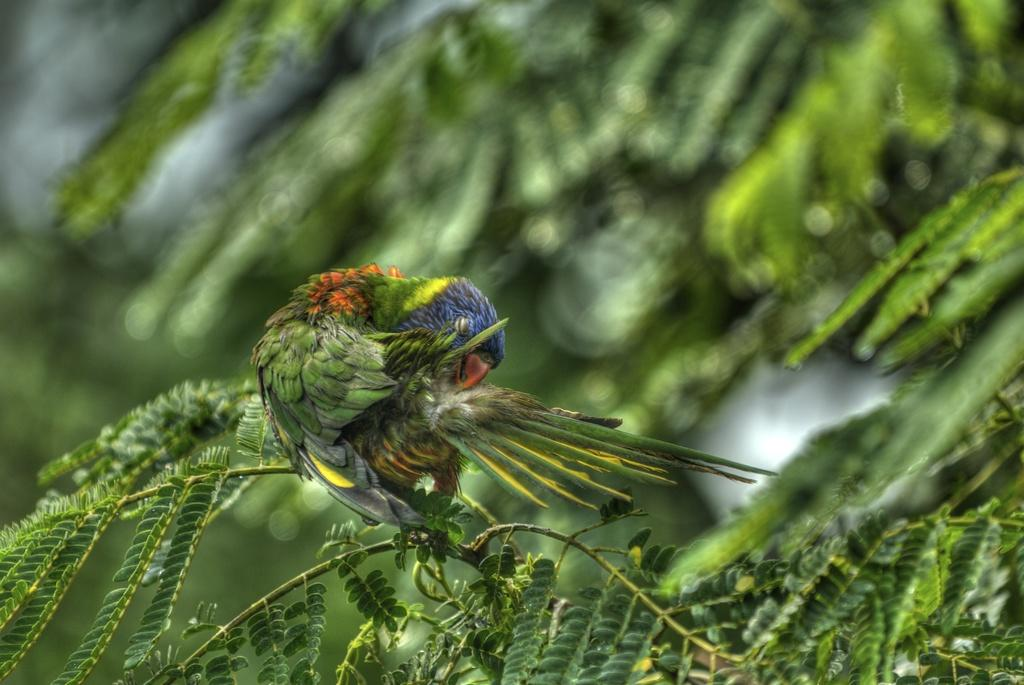What type of animal is in the image? There is a parrot in the image. What other objects can be seen in the image besides the parrot? There are leaves with stems in the image. Can you describe the background of the image? The background has a blurred view. What type of toy can be seen in the image? There is no toy present in the image. How does the heat affect the parrot in the image? The image does not provide information about the temperature or heat, so it cannot be determined how it affects the parrot. 